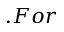<formula> <loc_0><loc_0><loc_500><loc_500>. F o r</formula> 